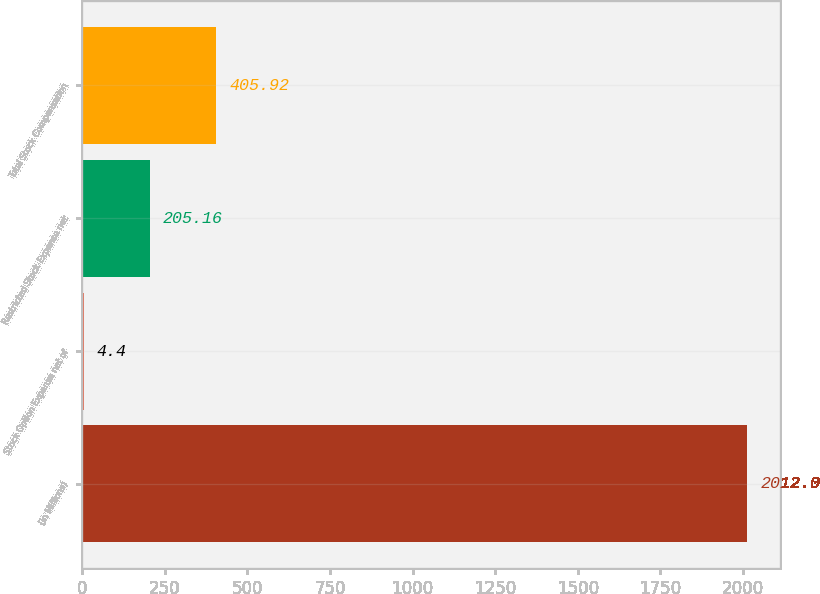Convert chart to OTSL. <chart><loc_0><loc_0><loc_500><loc_500><bar_chart><fcel>(in Millions)<fcel>Stock Option Expense net of<fcel>Restricted Stock Expense net<fcel>Total Stock Compensation<nl><fcel>2012<fcel>4.4<fcel>205.16<fcel>405.92<nl></chart> 